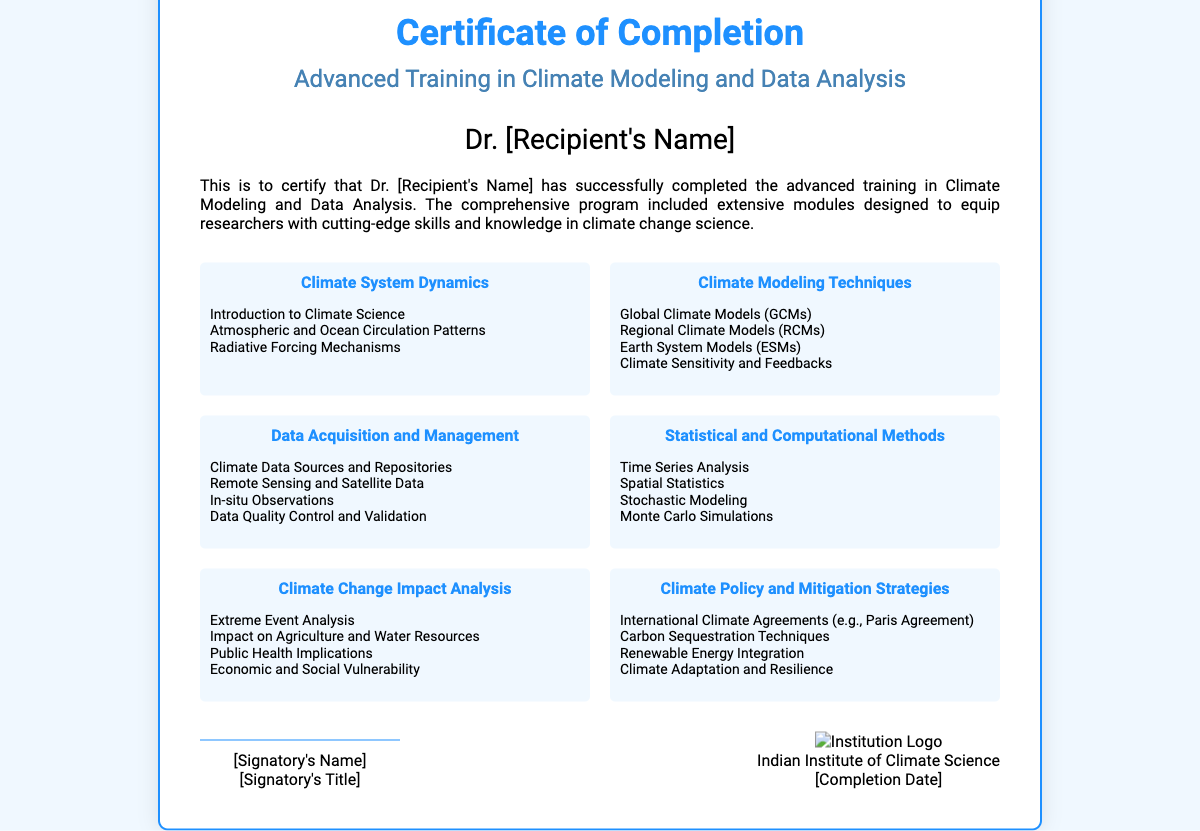What is the title of the course? The title of the course is located in the subtitle section of the certificate.
Answer: Advanced Training in Climate Modeling and Data Analysis Who is the recipient of the certificate? The recipient's name is displayed prominently in the certificate.
Answer: Dr. [Recipient's Name] What is one topic covered under Climate System Dynamics? The topics under Climate System Dynamics are listed in bullet points, and one example is taken from there.
Answer: Atmospheric and Ocean Circulation Patterns How many modules are included in the training? The document states that it is a comprehensive program, implying multiple modules, but does not specify a number.
Answer: Not specified What is one topic found in Climate Policy and Mitigation Strategies? The bullet points under Climate Policy and Mitigation Strategies list various topics, of which one can be selected.
Answer: Carbon Sequestration Techniques Who signed the certificate? The signatory's name is located in the footer section of the document.
Answer: [Signatory's Name] What institution issued this certificate? The institution's name is included in the footer section of the certificate.
Answer: Indian Institute of Climate Science What is the nature of the program mentioned in the certificate? The description provides clarity about the program offered within the certificate.
Answer: Advanced training What is one method highlighted under Statistical and Computational Methods? The document lists several methods, and one can be selected as an example from the topic section.
Answer: Time Series Analysis 